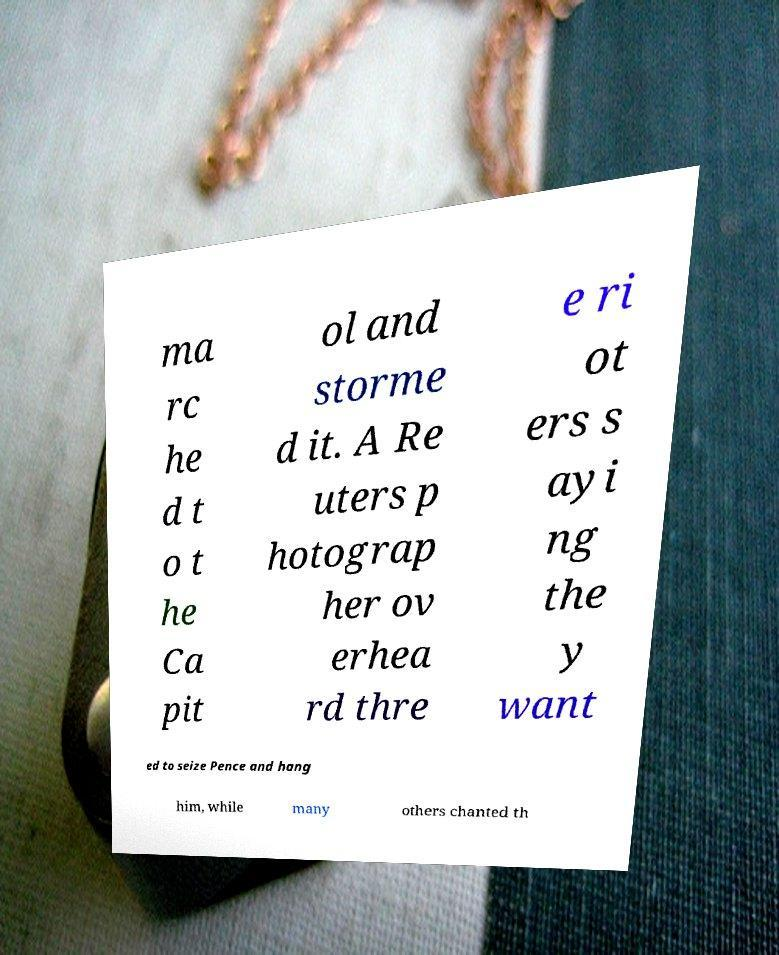Could you extract and type out the text from this image? ma rc he d t o t he Ca pit ol and storme d it. A Re uters p hotograp her ov erhea rd thre e ri ot ers s ayi ng the y want ed to seize Pence and hang him, while many others chanted th 